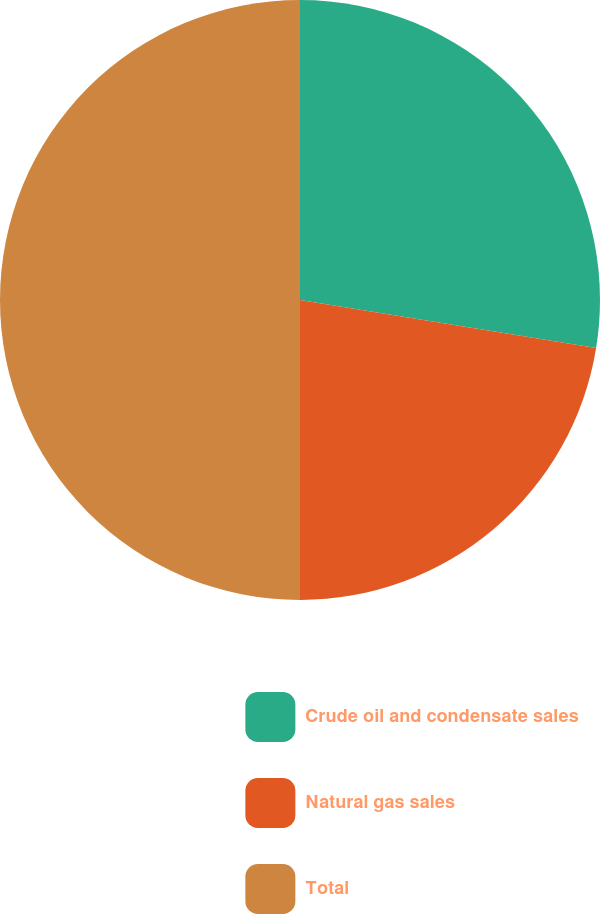Convert chart. <chart><loc_0><loc_0><loc_500><loc_500><pie_chart><fcel>Crude oil and condensate sales<fcel>Natural gas sales<fcel>Total<nl><fcel>27.56%<fcel>22.44%<fcel>50.0%<nl></chart> 